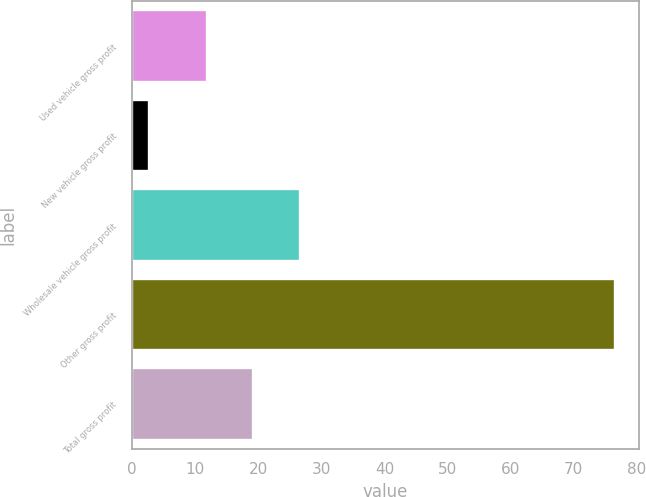<chart> <loc_0><loc_0><loc_500><loc_500><bar_chart><fcel>Used vehicle gross profit<fcel>New vehicle gross profit<fcel>Wholesale vehicle gross profit<fcel>Other gross profit<fcel>Total gross profit<nl><fcel>11.8<fcel>2.7<fcel>26.56<fcel>76.5<fcel>19.18<nl></chart> 